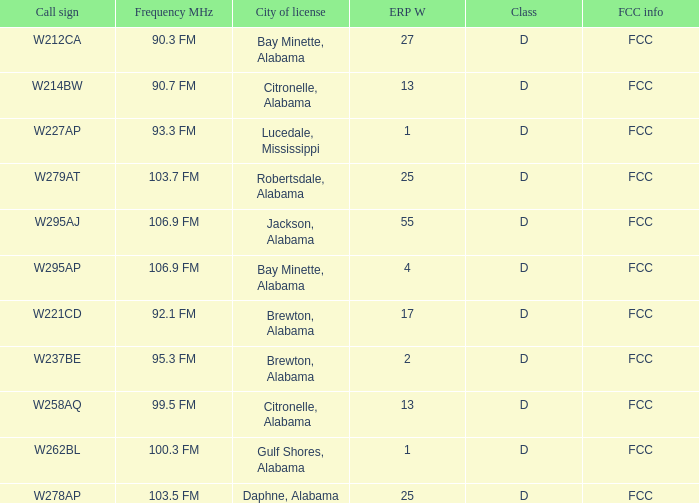Tell me the city of license with frequency of Mhz of 90.3 fm Bay Minette, Alabama. 